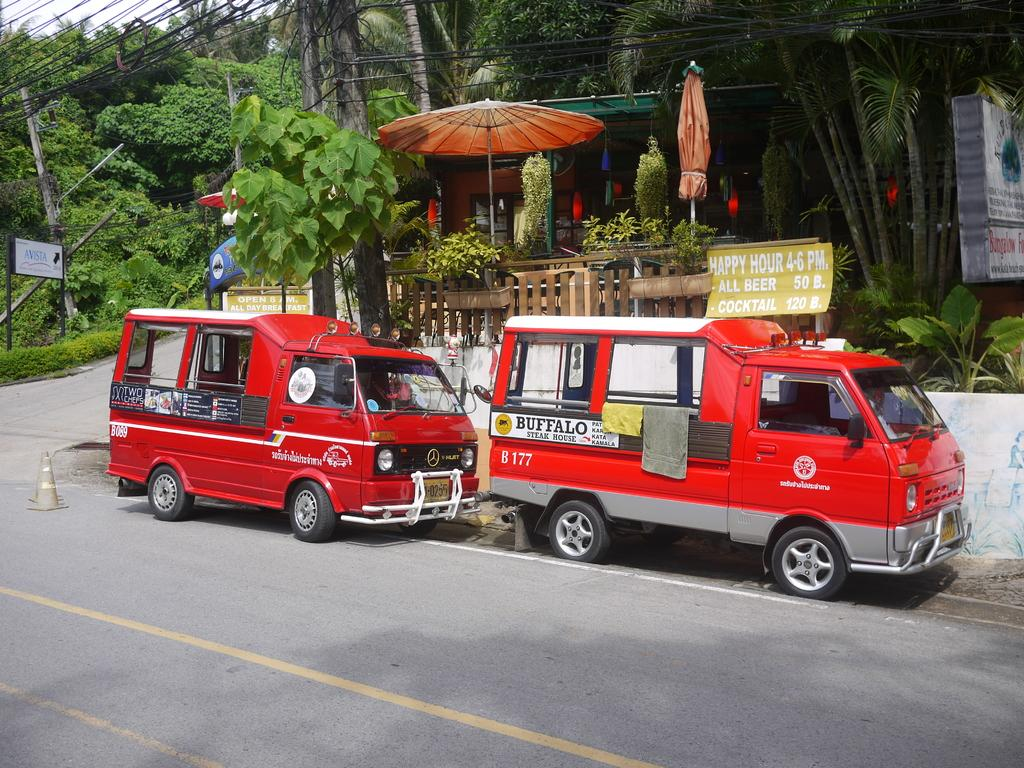What type of vehicles can be seen on the road in the image? There are two red vehicles on the road in the image. What objects are present in the background of the image? There are two brown umbrellas and green trees in the background of the image. What is the color of the sky in the image? The sky is white in color in the image. How many pies are being held by the cow in the image? There is no cow or pies present in the image. What is the relation between the two red vehicles and the green trees in the image? The provided facts do not mention any relation between the vehicles and trees; they are simply separate elements in the image. 